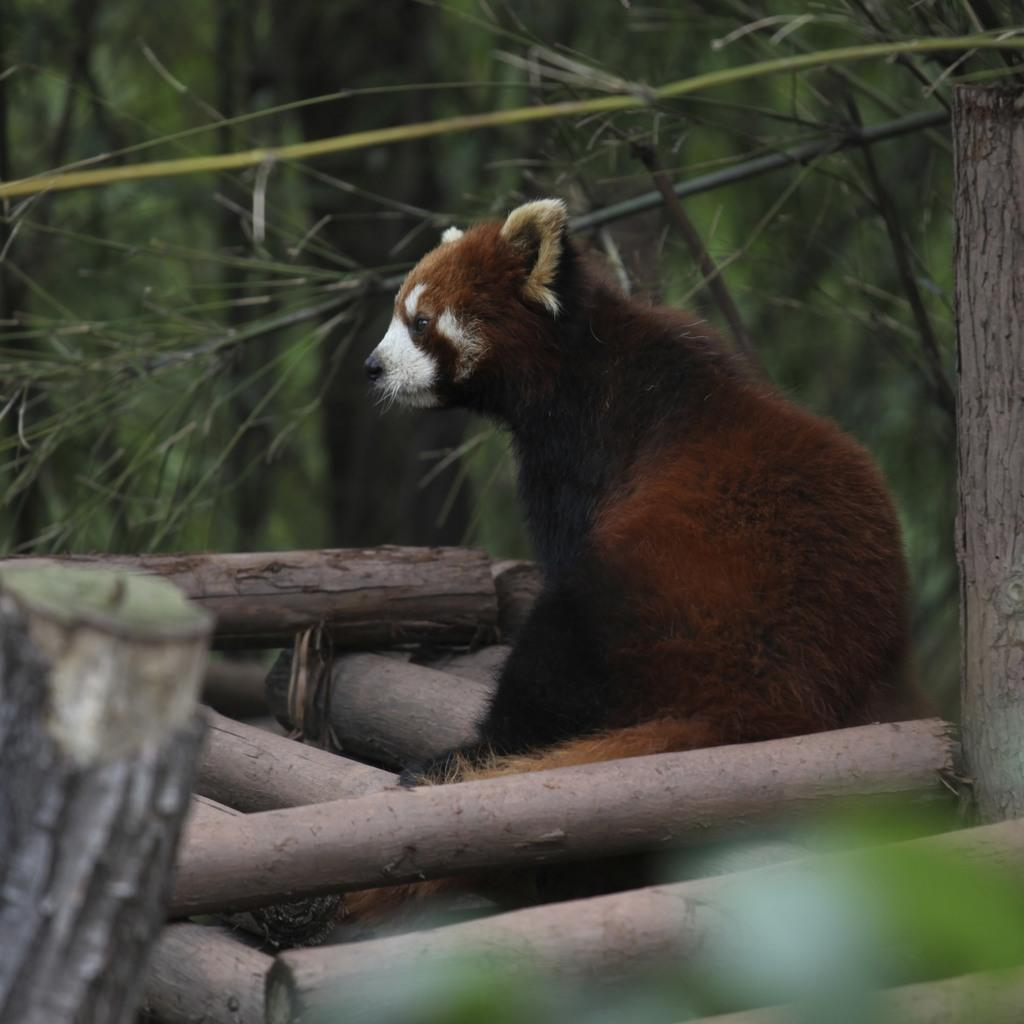What type of animal can be seen in the image? There is a brown-colored animal in the image. What can be seen in the background of the image? There are trees in the background of the image. How would you describe the quality of the image? The image is slightly blurry in the background. What type of basin is visible in the image? There is no basin present in the image. What is your opinion on the animal's behavior in the image? The image does not provide any information about the animal's behavior, so it is not possible to form an opinion. 